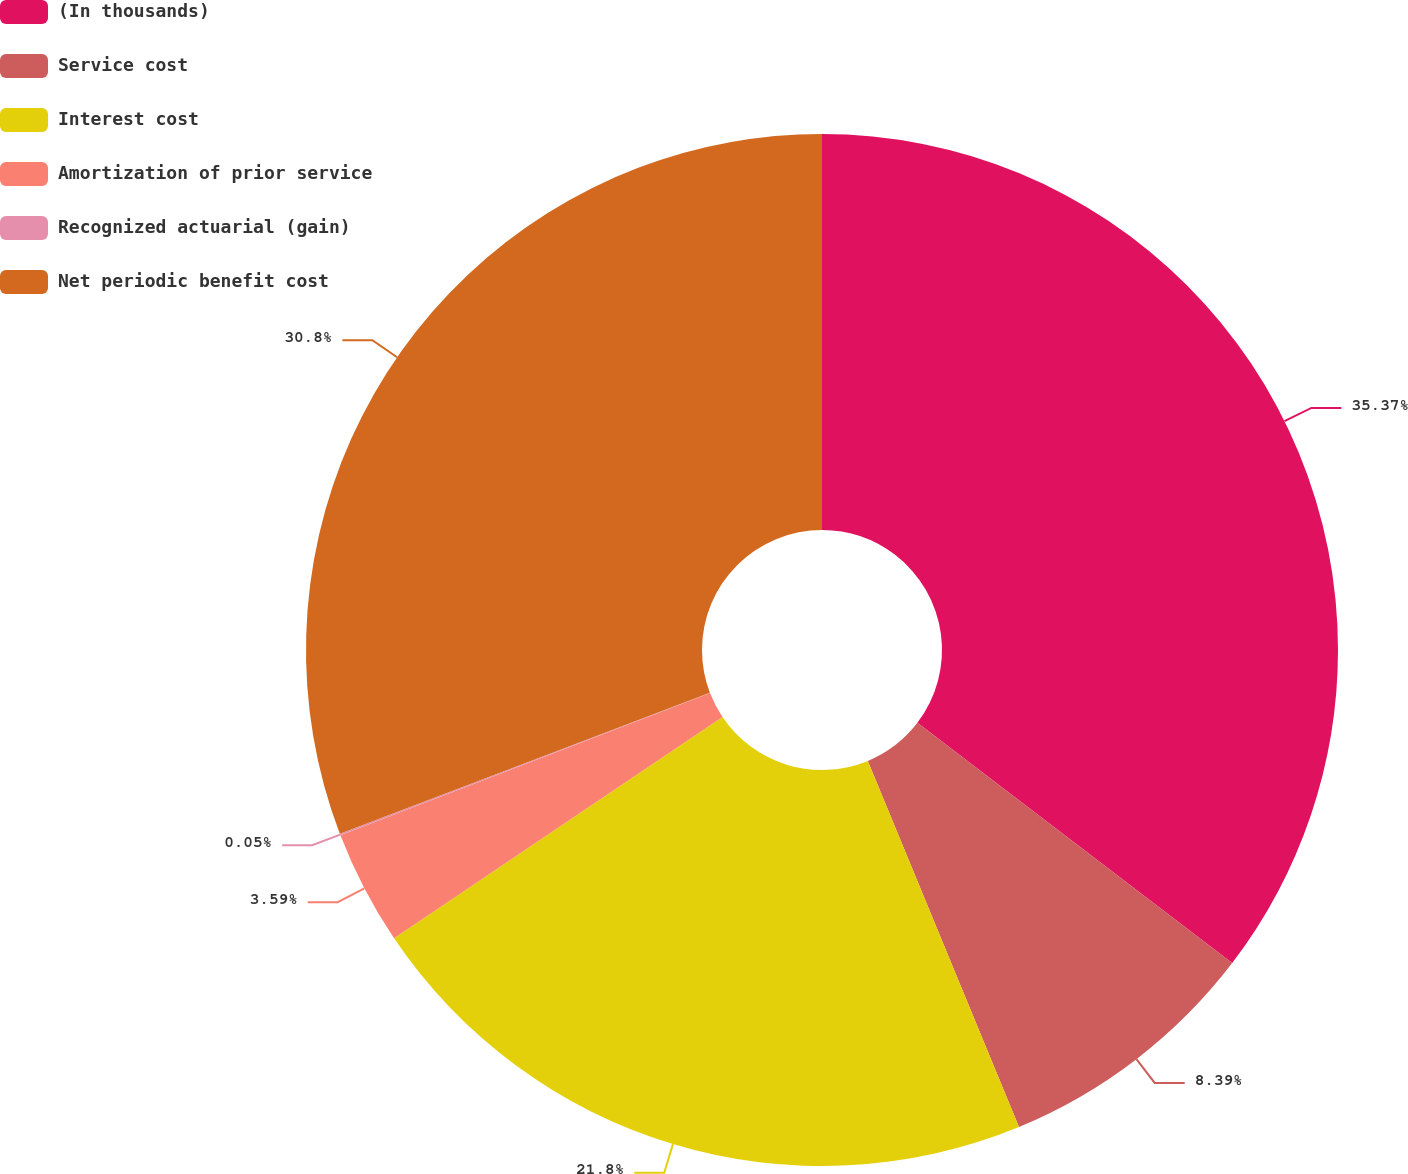<chart> <loc_0><loc_0><loc_500><loc_500><pie_chart><fcel>(In thousands)<fcel>Service cost<fcel>Interest cost<fcel>Amortization of prior service<fcel>Recognized actuarial (gain)<fcel>Net periodic benefit cost<nl><fcel>35.38%<fcel>8.39%<fcel>21.8%<fcel>3.59%<fcel>0.05%<fcel>30.8%<nl></chart> 